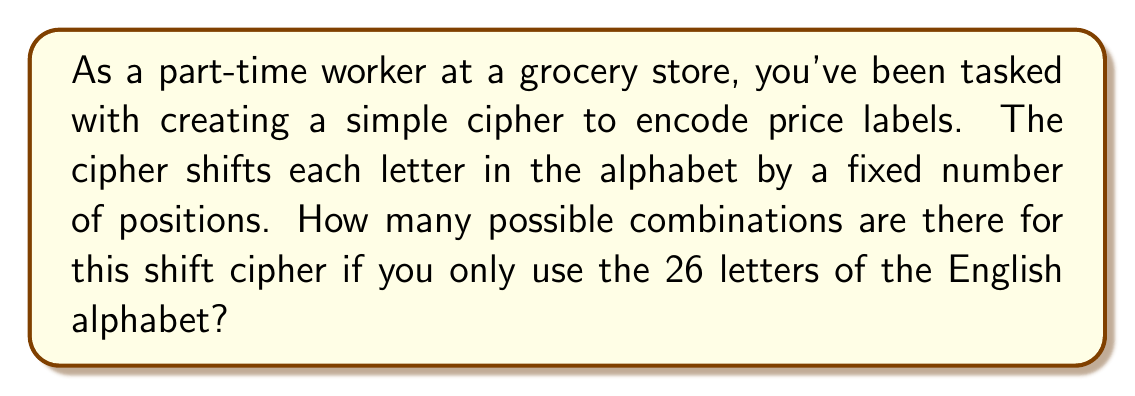Could you help me with this problem? Let's approach this step-by-step:

1) In a shift cipher, each letter is shifted by a fixed number of positions in the alphabet.

2) The number of possible shifts is determined by the number of letters in the alphabet.

3) In this case, we're using the English alphabet, which has 26 letters.

4) We can shift the alphabet by 0 positions (no change) up to 25 positions.

5) Shifting by 26 positions would be equivalent to shifting by 0 positions, so we don't count it as a separate combination.

6) Therefore, the number of possible combinations is equal to the number of possible shifts.

7) We can represent this mathematically as:

   $$\text{Number of combinations} = \text{Number of letters in alphabet}$$

8) Substituting our value:

   $$\text{Number of combinations} = 26$$

Thus, there are 26 possible combinations for this simple shift cipher using the English alphabet.
Answer: 26 